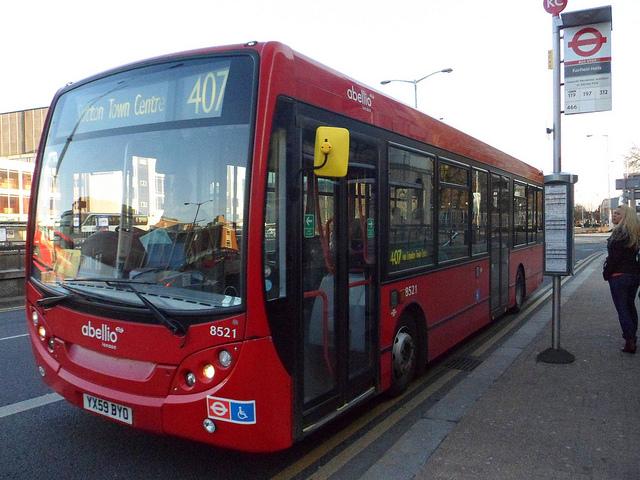How many levels are on the bus?
Keep it brief. 1. What number is on the bus?
Be succinct. 407. Is the  bus handicap accessible?
Quick response, please. Yes. Are the bus doors open?
Answer briefly. No. What type of bus is this?
Give a very brief answer. Commuter. How many levels is the bus?
Quick response, please. 1. What does the text writing say on the front of the bus?
Quick response, please. Abellio. 